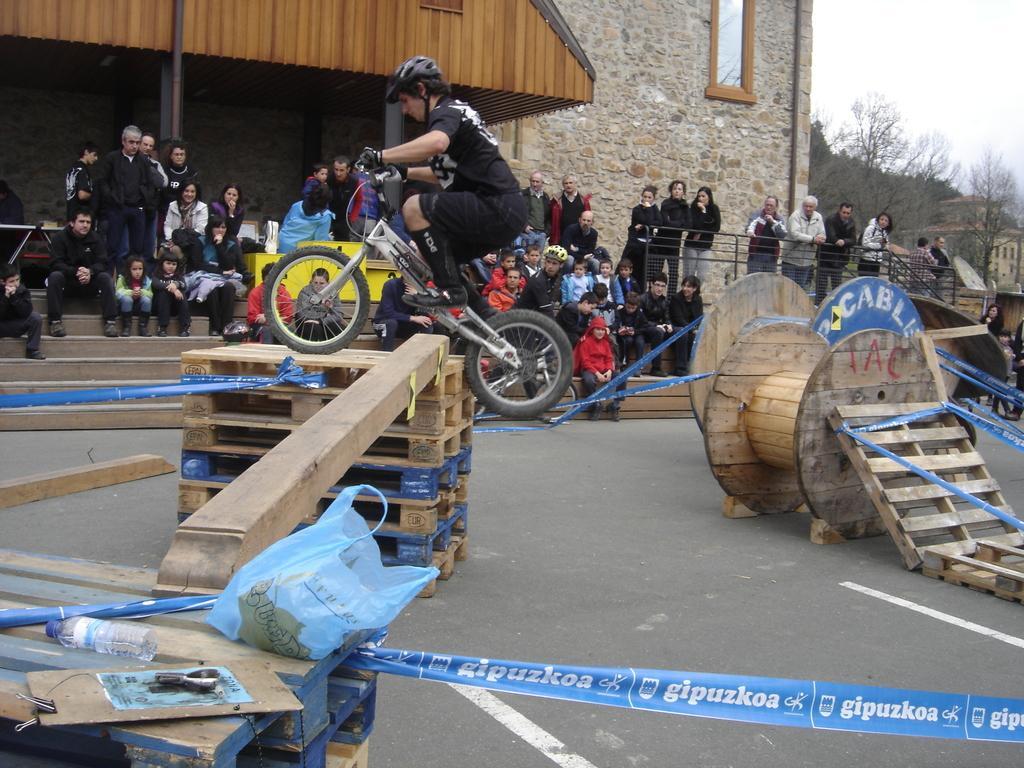Describe this image in one or two sentences. In the middle a man is riding the cycle and jumping. This person wore black color dress, helmet. Many people are sitting on the stairs and observing him. On the right side there are trees in this image. 